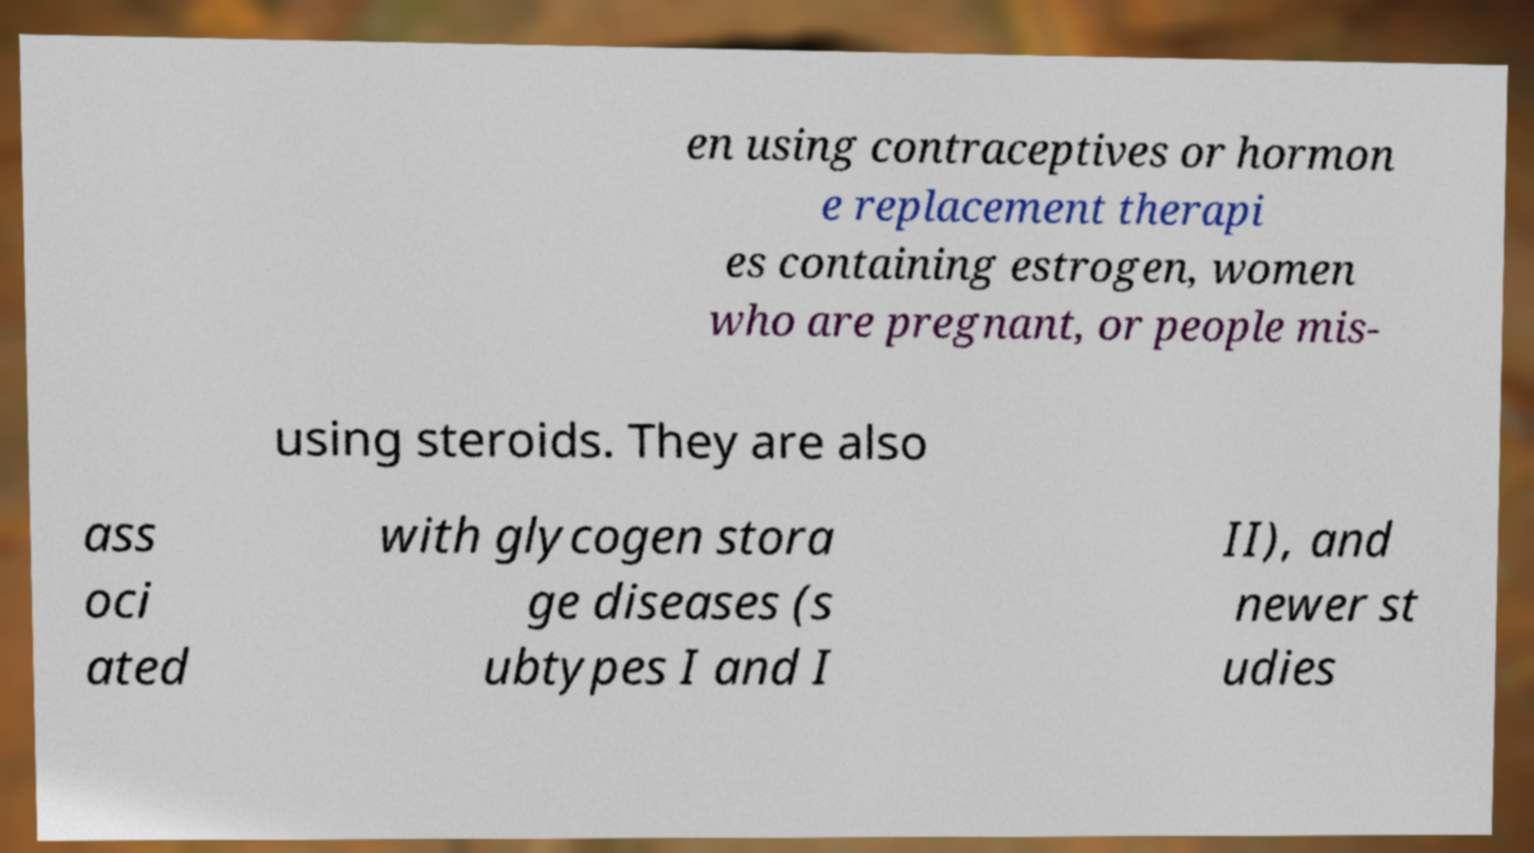There's text embedded in this image that I need extracted. Can you transcribe it verbatim? en using contraceptives or hormon e replacement therapi es containing estrogen, women who are pregnant, or people mis- using steroids. They are also ass oci ated with glycogen stora ge diseases (s ubtypes I and I II), and newer st udies 